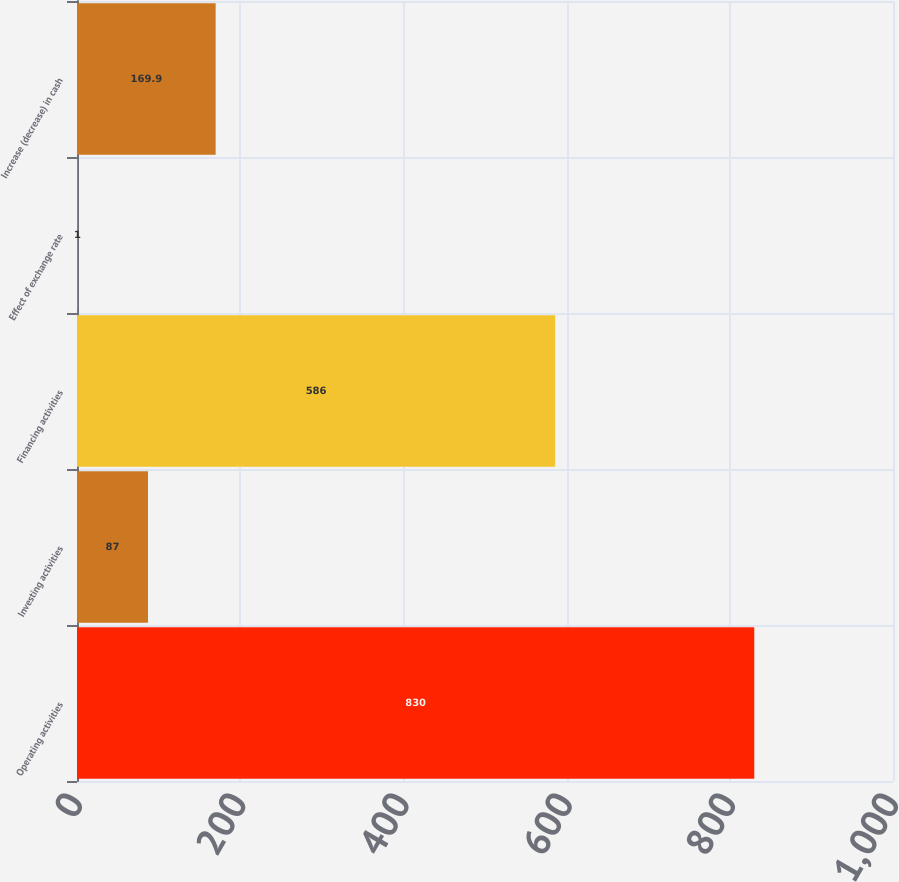Convert chart. <chart><loc_0><loc_0><loc_500><loc_500><bar_chart><fcel>Operating activities<fcel>Investing activities<fcel>Financing activities<fcel>Effect of exchange rate<fcel>Increase (decrease) in cash<nl><fcel>830<fcel>87<fcel>586<fcel>1<fcel>169.9<nl></chart> 